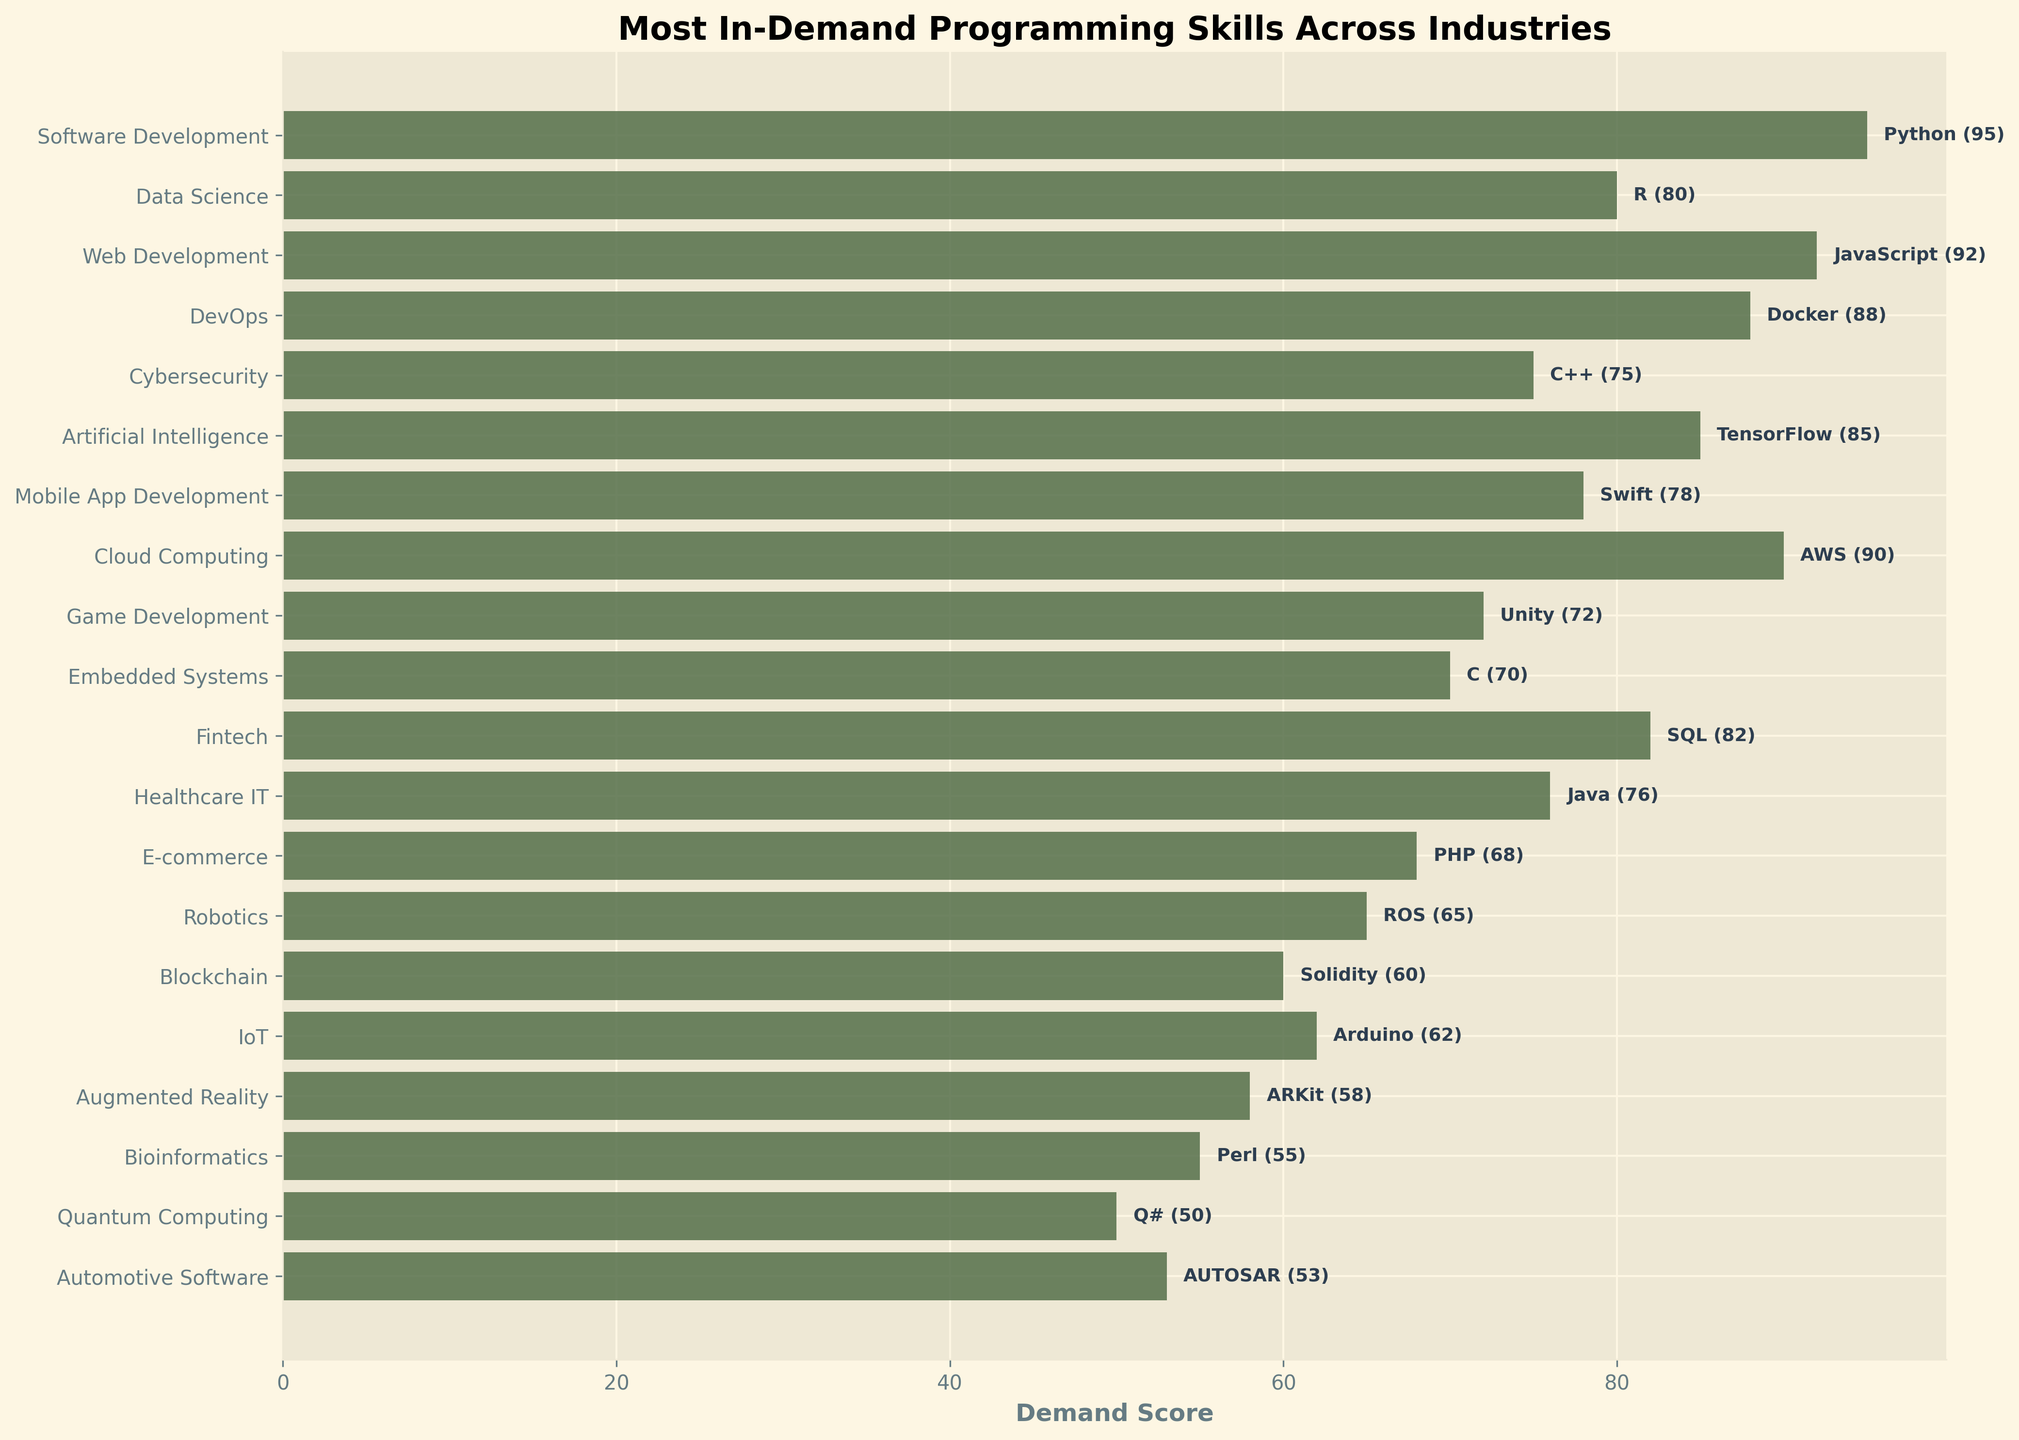Which industry has the highest demand score? Looking at the x-axis and comparing the length of bar charts for each industry, the tallest bar corresponds to the industry, which is "Software Development" with a demand score of 95.
Answer: Software Development Which skill is associated with the highest demand score? The Python skill is labeled with the highest demand score of 95 next to the bar representing "Software Development".
Answer: Python What is the sum of the demand scores for the industries "Cloud Computing" and "DevOps"? The demand scores for "Cloud Computing" and "DevOps" are 90 and 88 respectively. Adding 90 and 88 gives 178.
Answer: 178 Is the demand score for "Web Development" higher or lower than "Data Science"? The demand score for "Web Development" (JavaScript) is 92, which is higher than the demand score for "Data Science" (R) which is 80.
Answer: Higher Which industries have a demand score less than 60? The industries with demand scores less than 60 are "Blockchain", "IoT", "Augmented Reality", "Bioinformatics", and "Automotive Software" with respective scores of 60, 62, 58, 55, and 53.
Answer: Blockchain, IoT, Augmented Reality, Bioinformatics, Automotive Software What is the average demand score of the skills associated with "E-commerce", "Robotics", and "Quantum Computing"? The demand scores for "E-commerce", "Robotics", and "Quantum Computing" are 68, 65, and 50 respectively. The average is calculated as (68 + 65 + 50) / 3 = 61.
Answer: 61 Compare the length of the demand score bars for "Embedded Systems" and "Game Development". Which one is longer? The demand score for "Embedded Systems" is 70, while for "Game Development" it is 72. The bar for "Game Development" is slightly longer.
Answer: Game Development What is the difference between the highest and lowest demand scores in the dataset? The highest demand score is 95 (Software Development) and the lowest demand score is 50 (Quantum Computing). The difference is 95 - 50 = 45.
Answer: 45 What is the total demand score for all industries starting with the letter 'C'? The industries starting with 'C' are "Cybersecurity" with a score of 75 and "Cloud Computing" with a score of 90. The total is 75 + 90 = 165.
Answer: 165 Which industry has the closest demand score to 70? The demand score closest to 70 is for "Embedded Systems", which exactly has a demand score of 70.
Answer: Embedded Systems 